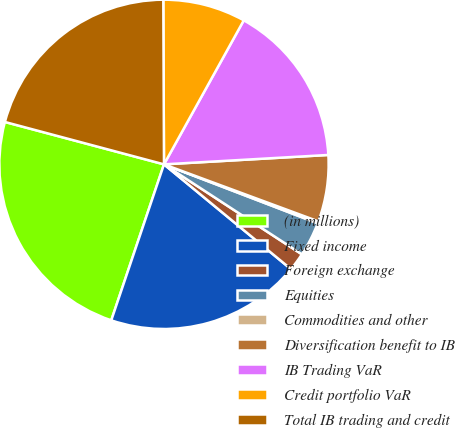Convert chart. <chart><loc_0><loc_0><loc_500><loc_500><pie_chart><fcel>(in millions)<fcel>Fixed income<fcel>Foreign exchange<fcel>Equities<fcel>Commodities and other<fcel>Diversification benefit to IB<fcel>IB Trading VaR<fcel>Credit portfolio VaR<fcel>Total IB trading and credit<nl><fcel>23.96%<fcel>19.21%<fcel>1.78%<fcel>3.37%<fcel>0.2%<fcel>6.54%<fcel>16.04%<fcel>8.12%<fcel>20.79%<nl></chart> 